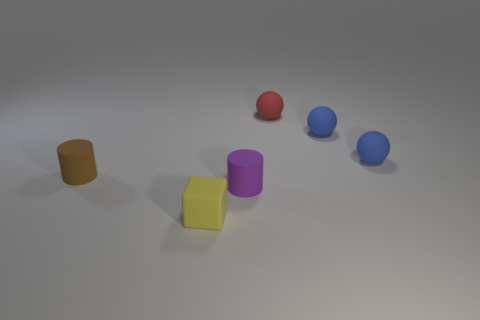Add 3 cyan blocks. How many objects exist? 9 Subtract all cylinders. How many objects are left? 4 Subtract 0 gray blocks. How many objects are left? 6 Subtract all big red shiny things. Subtract all blue rubber balls. How many objects are left? 4 Add 5 tiny blue balls. How many tiny blue balls are left? 7 Add 1 red rubber objects. How many red rubber objects exist? 2 